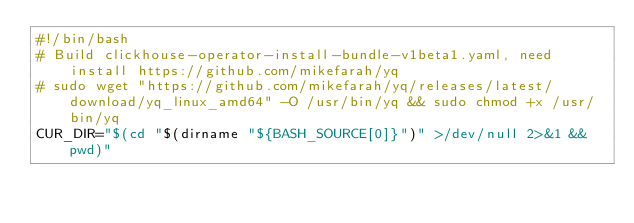Convert code to text. <code><loc_0><loc_0><loc_500><loc_500><_Bash_>#!/bin/bash
# Build clickhouse-operator-install-bundle-v1beta1.yaml, need install https://github.com/mikefarah/yq
# sudo wget "https://github.com/mikefarah/yq/releases/latest/download/yq_linux_amd64" -O /usr/bin/yq && sudo chmod +x /usr/bin/yq
CUR_DIR="$(cd "$(dirname "${BASH_SOURCE[0]}")" >/dev/null 2>&1 && pwd)"</code> 